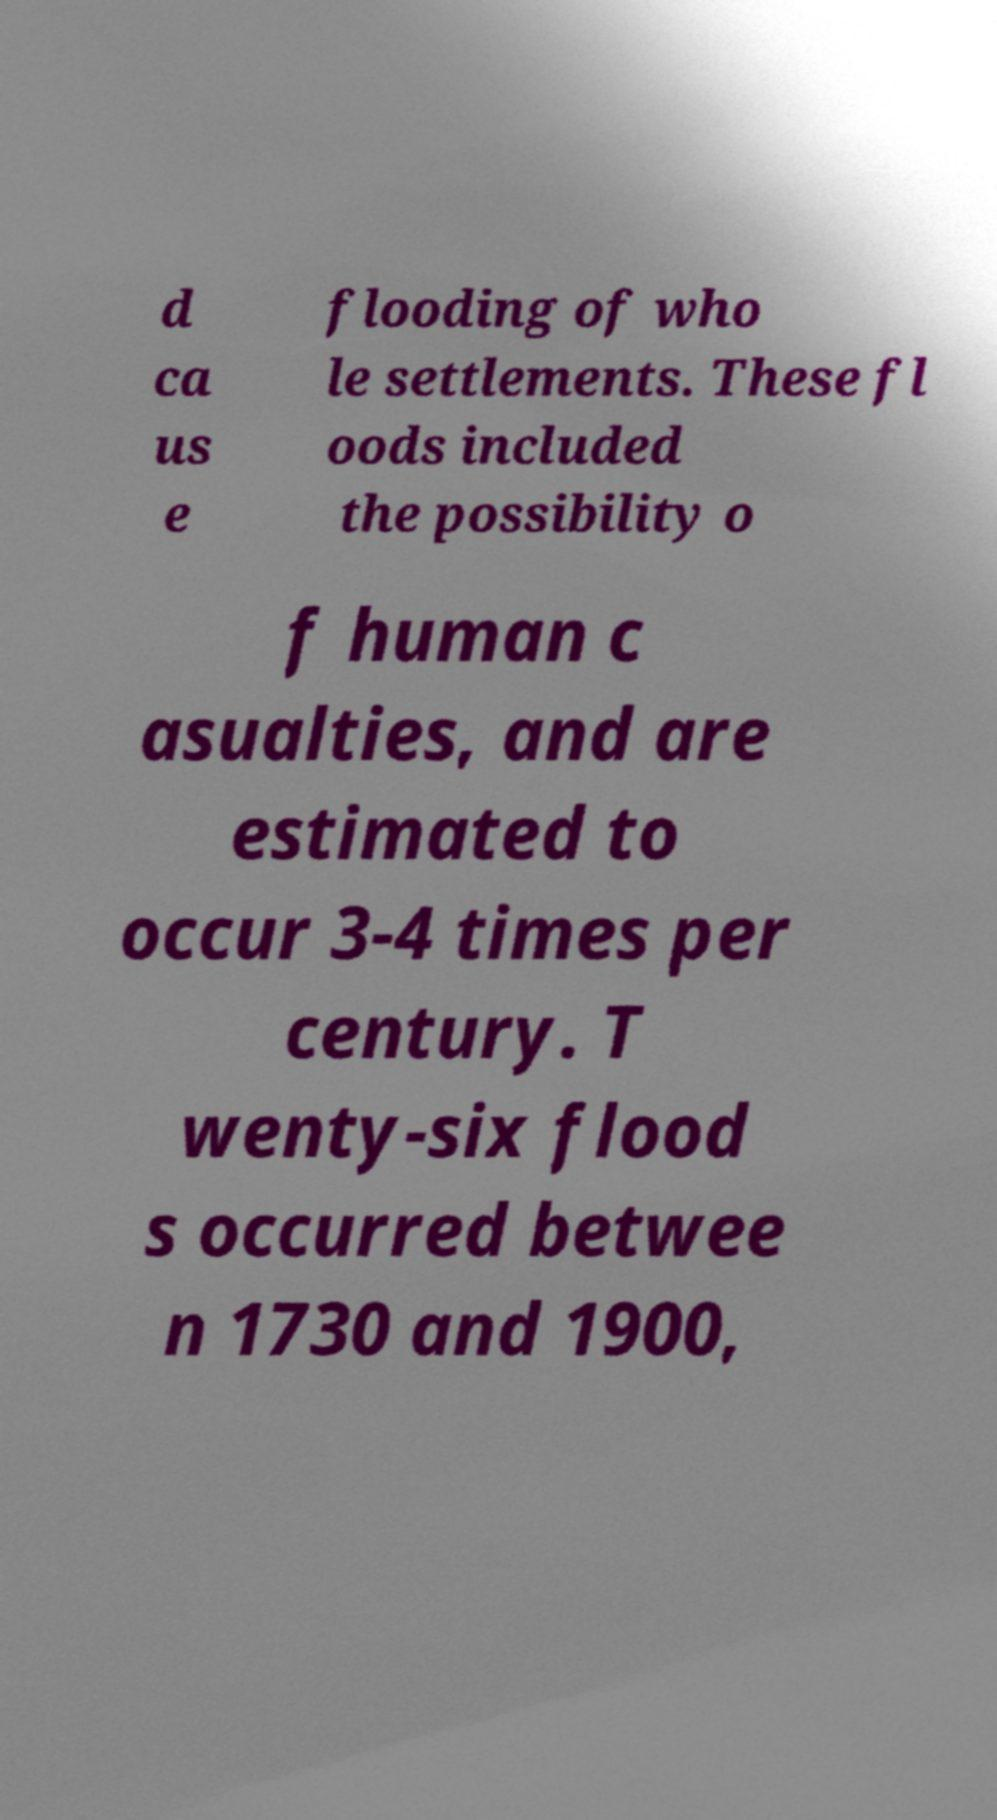There's text embedded in this image that I need extracted. Can you transcribe it verbatim? d ca us e flooding of who le settlements. These fl oods included the possibility o f human c asualties, and are estimated to occur 3-4 times per century. T wenty-six flood s occurred betwee n 1730 and 1900, 